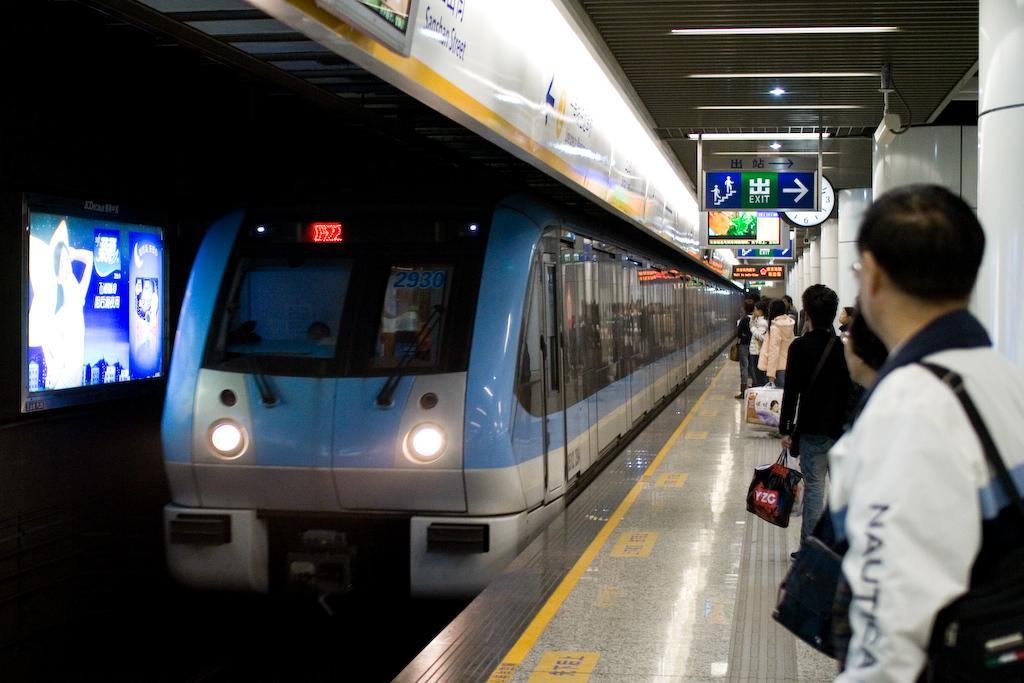Describe this image in one or two sentences. In this image I can see the train which is in blue and ash color. To the left I can see the screen. To the right there are the group of people standing on the platform. These people are wearing the different color dresses and also holding the bags. In the background I can see the boards and clock. 